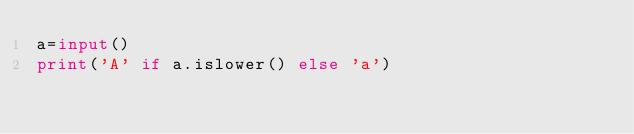Convert code to text. <code><loc_0><loc_0><loc_500><loc_500><_Python_>a=input()
print('A' if a.islower() else 'a')</code> 